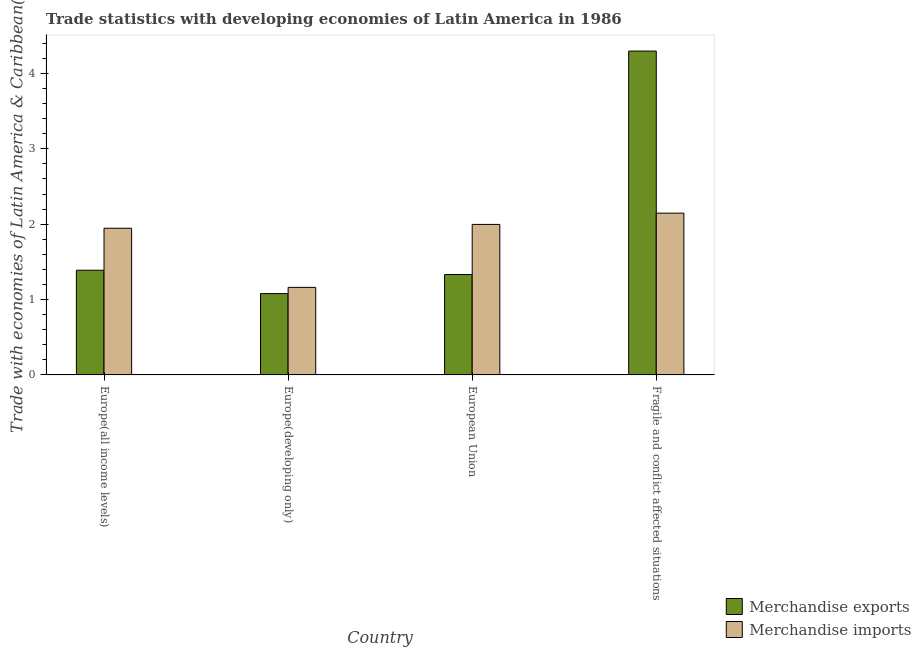How many groups of bars are there?
Your answer should be very brief. 4. Are the number of bars per tick equal to the number of legend labels?
Offer a terse response. Yes. Are the number of bars on each tick of the X-axis equal?
Make the answer very short. Yes. How many bars are there on the 3rd tick from the right?
Offer a terse response. 2. What is the label of the 4th group of bars from the left?
Your answer should be compact. Fragile and conflict affected situations. What is the merchandise imports in Europe(developing only)?
Provide a short and direct response. 1.16. Across all countries, what is the maximum merchandise exports?
Offer a very short reply. 4.3. Across all countries, what is the minimum merchandise imports?
Provide a short and direct response. 1.16. In which country was the merchandise exports maximum?
Your answer should be very brief. Fragile and conflict affected situations. In which country was the merchandise imports minimum?
Provide a succinct answer. Europe(developing only). What is the total merchandise imports in the graph?
Ensure brevity in your answer.  7.25. What is the difference between the merchandise imports in European Union and that in Fragile and conflict affected situations?
Your answer should be very brief. -0.15. What is the difference between the merchandise exports in Fragile and conflict affected situations and the merchandise imports in Europe(developing only)?
Your response must be concise. 3.14. What is the average merchandise exports per country?
Your answer should be compact. 2.02. What is the difference between the merchandise exports and merchandise imports in Europe(all income levels)?
Ensure brevity in your answer.  -0.56. What is the ratio of the merchandise exports in Europe(all income levels) to that in Fragile and conflict affected situations?
Your answer should be very brief. 0.32. Is the difference between the merchandise exports in Europe(all income levels) and Fragile and conflict affected situations greater than the difference between the merchandise imports in Europe(all income levels) and Fragile and conflict affected situations?
Provide a succinct answer. No. What is the difference between the highest and the second highest merchandise exports?
Make the answer very short. 2.91. What is the difference between the highest and the lowest merchandise imports?
Provide a succinct answer. 0.98. How many bars are there?
Offer a terse response. 8. Are all the bars in the graph horizontal?
Your answer should be very brief. No. How many countries are there in the graph?
Your answer should be compact. 4. Are the values on the major ticks of Y-axis written in scientific E-notation?
Your answer should be very brief. No. Does the graph contain any zero values?
Offer a very short reply. No. Does the graph contain grids?
Offer a terse response. No. Where does the legend appear in the graph?
Make the answer very short. Bottom right. How are the legend labels stacked?
Give a very brief answer. Vertical. What is the title of the graph?
Ensure brevity in your answer.  Trade statistics with developing economies of Latin America in 1986. Does "Electricity" appear as one of the legend labels in the graph?
Keep it short and to the point. No. What is the label or title of the X-axis?
Give a very brief answer. Country. What is the label or title of the Y-axis?
Offer a very short reply. Trade with economies of Latin America & Caribbean(%). What is the Trade with economies of Latin America & Caribbean(%) of Merchandise exports in Europe(all income levels)?
Provide a succinct answer. 1.39. What is the Trade with economies of Latin America & Caribbean(%) in Merchandise imports in Europe(all income levels)?
Offer a terse response. 1.95. What is the Trade with economies of Latin America & Caribbean(%) of Merchandise exports in Europe(developing only)?
Give a very brief answer. 1.08. What is the Trade with economies of Latin America & Caribbean(%) of Merchandise imports in Europe(developing only)?
Ensure brevity in your answer.  1.16. What is the Trade with economies of Latin America & Caribbean(%) in Merchandise exports in European Union?
Keep it short and to the point. 1.33. What is the Trade with economies of Latin America & Caribbean(%) of Merchandise imports in European Union?
Provide a succinct answer. 2. What is the Trade with economies of Latin America & Caribbean(%) in Merchandise exports in Fragile and conflict affected situations?
Your answer should be compact. 4.3. What is the Trade with economies of Latin America & Caribbean(%) in Merchandise imports in Fragile and conflict affected situations?
Provide a short and direct response. 2.15. Across all countries, what is the maximum Trade with economies of Latin America & Caribbean(%) in Merchandise exports?
Make the answer very short. 4.3. Across all countries, what is the maximum Trade with economies of Latin America & Caribbean(%) of Merchandise imports?
Keep it short and to the point. 2.15. Across all countries, what is the minimum Trade with economies of Latin America & Caribbean(%) in Merchandise exports?
Give a very brief answer. 1.08. Across all countries, what is the minimum Trade with economies of Latin America & Caribbean(%) of Merchandise imports?
Offer a very short reply. 1.16. What is the total Trade with economies of Latin America & Caribbean(%) in Merchandise exports in the graph?
Keep it short and to the point. 8.1. What is the total Trade with economies of Latin America & Caribbean(%) in Merchandise imports in the graph?
Provide a short and direct response. 7.25. What is the difference between the Trade with economies of Latin America & Caribbean(%) of Merchandise exports in Europe(all income levels) and that in Europe(developing only)?
Your answer should be compact. 0.31. What is the difference between the Trade with economies of Latin America & Caribbean(%) in Merchandise imports in Europe(all income levels) and that in Europe(developing only)?
Offer a terse response. 0.78. What is the difference between the Trade with economies of Latin America & Caribbean(%) of Merchandise exports in Europe(all income levels) and that in European Union?
Provide a succinct answer. 0.06. What is the difference between the Trade with economies of Latin America & Caribbean(%) of Merchandise imports in Europe(all income levels) and that in European Union?
Make the answer very short. -0.05. What is the difference between the Trade with economies of Latin America & Caribbean(%) of Merchandise exports in Europe(all income levels) and that in Fragile and conflict affected situations?
Offer a terse response. -2.91. What is the difference between the Trade with economies of Latin America & Caribbean(%) in Merchandise imports in Europe(all income levels) and that in Fragile and conflict affected situations?
Provide a short and direct response. -0.2. What is the difference between the Trade with economies of Latin America & Caribbean(%) of Merchandise exports in Europe(developing only) and that in European Union?
Your answer should be very brief. -0.25. What is the difference between the Trade with economies of Latin America & Caribbean(%) in Merchandise imports in Europe(developing only) and that in European Union?
Your response must be concise. -0.84. What is the difference between the Trade with economies of Latin America & Caribbean(%) in Merchandise exports in Europe(developing only) and that in Fragile and conflict affected situations?
Ensure brevity in your answer.  -3.22. What is the difference between the Trade with economies of Latin America & Caribbean(%) in Merchandise imports in Europe(developing only) and that in Fragile and conflict affected situations?
Your answer should be compact. -0.98. What is the difference between the Trade with economies of Latin America & Caribbean(%) in Merchandise exports in European Union and that in Fragile and conflict affected situations?
Provide a succinct answer. -2.97. What is the difference between the Trade with economies of Latin America & Caribbean(%) in Merchandise imports in European Union and that in Fragile and conflict affected situations?
Keep it short and to the point. -0.15. What is the difference between the Trade with economies of Latin America & Caribbean(%) of Merchandise exports in Europe(all income levels) and the Trade with economies of Latin America & Caribbean(%) of Merchandise imports in Europe(developing only)?
Make the answer very short. 0.23. What is the difference between the Trade with economies of Latin America & Caribbean(%) of Merchandise exports in Europe(all income levels) and the Trade with economies of Latin America & Caribbean(%) of Merchandise imports in European Union?
Give a very brief answer. -0.61. What is the difference between the Trade with economies of Latin America & Caribbean(%) in Merchandise exports in Europe(all income levels) and the Trade with economies of Latin America & Caribbean(%) in Merchandise imports in Fragile and conflict affected situations?
Give a very brief answer. -0.76. What is the difference between the Trade with economies of Latin America & Caribbean(%) of Merchandise exports in Europe(developing only) and the Trade with economies of Latin America & Caribbean(%) of Merchandise imports in European Union?
Give a very brief answer. -0.92. What is the difference between the Trade with economies of Latin America & Caribbean(%) of Merchandise exports in Europe(developing only) and the Trade with economies of Latin America & Caribbean(%) of Merchandise imports in Fragile and conflict affected situations?
Make the answer very short. -1.07. What is the difference between the Trade with economies of Latin America & Caribbean(%) of Merchandise exports in European Union and the Trade with economies of Latin America & Caribbean(%) of Merchandise imports in Fragile and conflict affected situations?
Provide a succinct answer. -0.81. What is the average Trade with economies of Latin America & Caribbean(%) of Merchandise exports per country?
Make the answer very short. 2.02. What is the average Trade with economies of Latin America & Caribbean(%) of Merchandise imports per country?
Offer a terse response. 1.81. What is the difference between the Trade with economies of Latin America & Caribbean(%) in Merchandise exports and Trade with economies of Latin America & Caribbean(%) in Merchandise imports in Europe(all income levels)?
Your response must be concise. -0.56. What is the difference between the Trade with economies of Latin America & Caribbean(%) in Merchandise exports and Trade with economies of Latin America & Caribbean(%) in Merchandise imports in Europe(developing only)?
Offer a terse response. -0.08. What is the difference between the Trade with economies of Latin America & Caribbean(%) of Merchandise exports and Trade with economies of Latin America & Caribbean(%) of Merchandise imports in European Union?
Your answer should be very brief. -0.67. What is the difference between the Trade with economies of Latin America & Caribbean(%) in Merchandise exports and Trade with economies of Latin America & Caribbean(%) in Merchandise imports in Fragile and conflict affected situations?
Make the answer very short. 2.15. What is the ratio of the Trade with economies of Latin America & Caribbean(%) of Merchandise exports in Europe(all income levels) to that in Europe(developing only)?
Give a very brief answer. 1.29. What is the ratio of the Trade with economies of Latin America & Caribbean(%) in Merchandise imports in Europe(all income levels) to that in Europe(developing only)?
Make the answer very short. 1.68. What is the ratio of the Trade with economies of Latin America & Caribbean(%) of Merchandise exports in Europe(all income levels) to that in European Union?
Your answer should be very brief. 1.04. What is the ratio of the Trade with economies of Latin America & Caribbean(%) of Merchandise imports in Europe(all income levels) to that in European Union?
Offer a terse response. 0.97. What is the ratio of the Trade with economies of Latin America & Caribbean(%) in Merchandise exports in Europe(all income levels) to that in Fragile and conflict affected situations?
Provide a succinct answer. 0.32. What is the ratio of the Trade with economies of Latin America & Caribbean(%) of Merchandise imports in Europe(all income levels) to that in Fragile and conflict affected situations?
Keep it short and to the point. 0.91. What is the ratio of the Trade with economies of Latin America & Caribbean(%) in Merchandise exports in Europe(developing only) to that in European Union?
Your response must be concise. 0.81. What is the ratio of the Trade with economies of Latin America & Caribbean(%) of Merchandise imports in Europe(developing only) to that in European Union?
Ensure brevity in your answer.  0.58. What is the ratio of the Trade with economies of Latin America & Caribbean(%) of Merchandise exports in Europe(developing only) to that in Fragile and conflict affected situations?
Provide a short and direct response. 0.25. What is the ratio of the Trade with economies of Latin America & Caribbean(%) of Merchandise imports in Europe(developing only) to that in Fragile and conflict affected situations?
Give a very brief answer. 0.54. What is the ratio of the Trade with economies of Latin America & Caribbean(%) of Merchandise exports in European Union to that in Fragile and conflict affected situations?
Ensure brevity in your answer.  0.31. What is the ratio of the Trade with economies of Latin America & Caribbean(%) of Merchandise imports in European Union to that in Fragile and conflict affected situations?
Give a very brief answer. 0.93. What is the difference between the highest and the second highest Trade with economies of Latin America & Caribbean(%) of Merchandise exports?
Offer a very short reply. 2.91. What is the difference between the highest and the second highest Trade with economies of Latin America & Caribbean(%) in Merchandise imports?
Your response must be concise. 0.15. What is the difference between the highest and the lowest Trade with economies of Latin America & Caribbean(%) in Merchandise exports?
Give a very brief answer. 3.22. What is the difference between the highest and the lowest Trade with economies of Latin America & Caribbean(%) of Merchandise imports?
Your answer should be very brief. 0.98. 